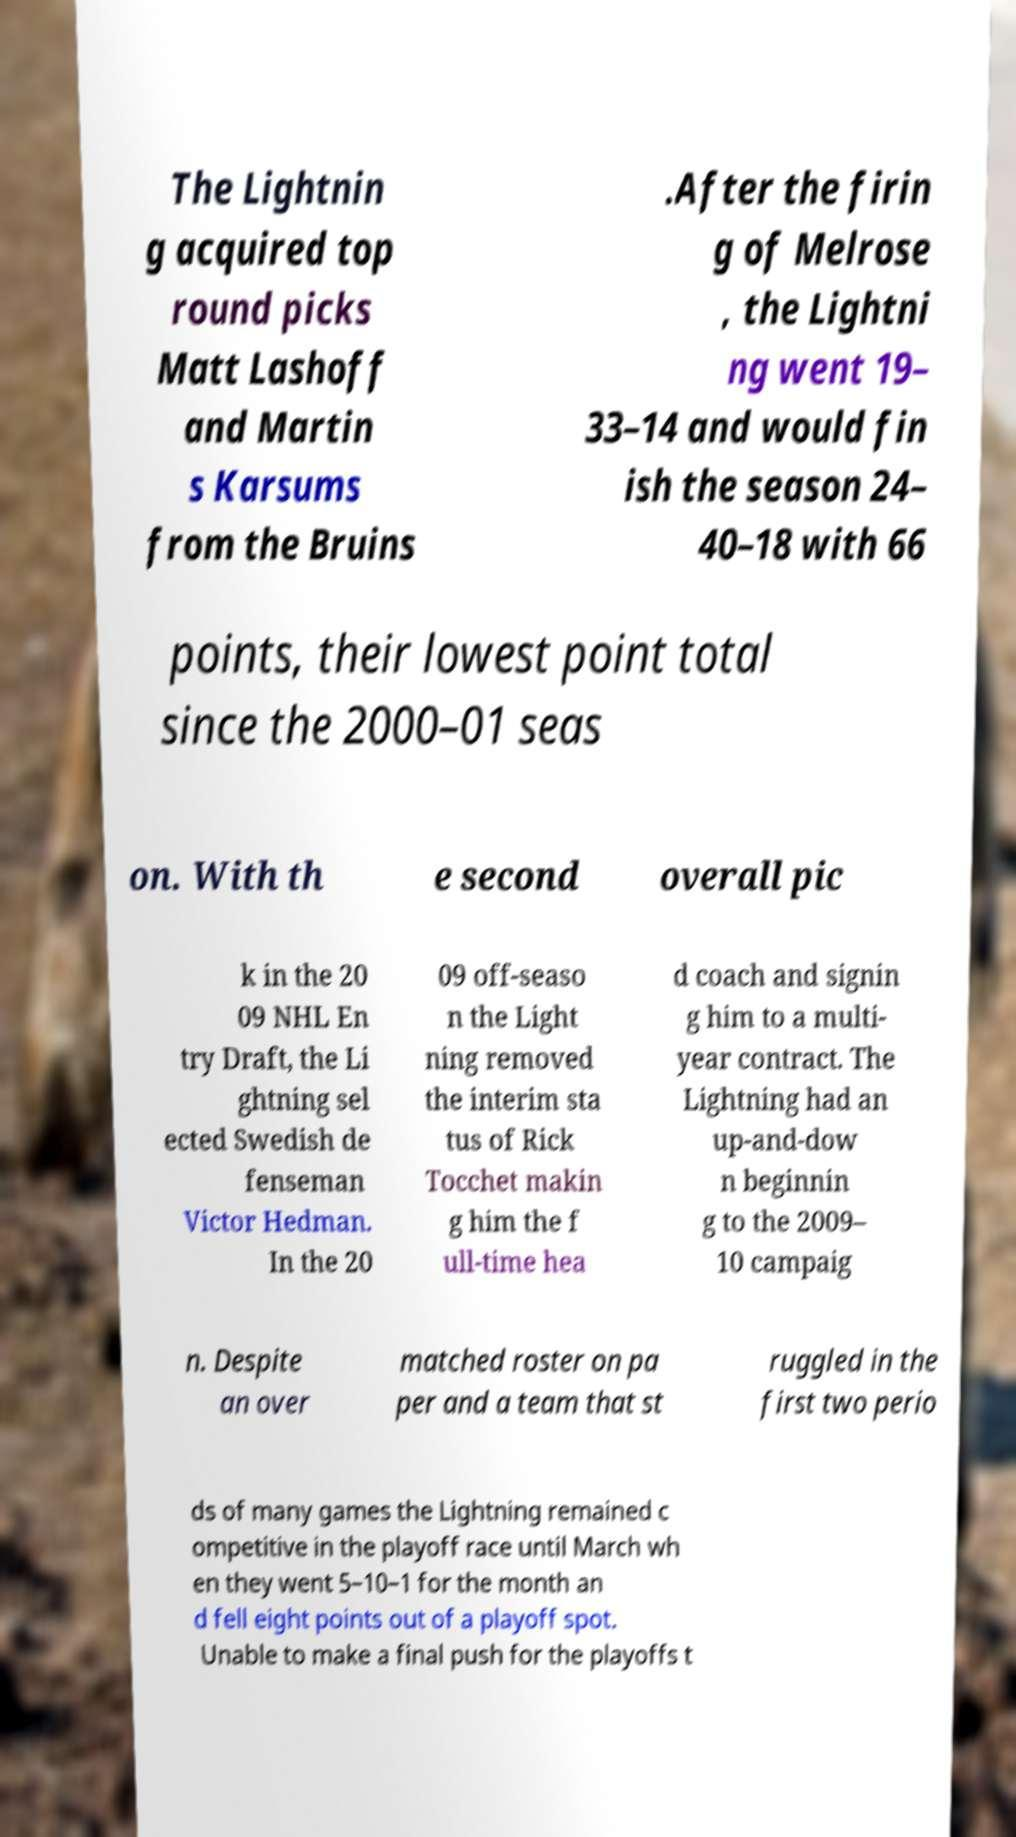Can you accurately transcribe the text from the provided image for me? The Lightnin g acquired top round picks Matt Lashoff and Martin s Karsums from the Bruins .After the firin g of Melrose , the Lightni ng went 19– 33–14 and would fin ish the season 24– 40–18 with 66 points, their lowest point total since the 2000–01 seas on. With th e second overall pic k in the 20 09 NHL En try Draft, the Li ghtning sel ected Swedish de fenseman Victor Hedman. In the 20 09 off-seaso n the Light ning removed the interim sta tus of Rick Tocchet makin g him the f ull-time hea d coach and signin g him to a multi- year contract. The Lightning had an up-and-dow n beginnin g to the 2009– 10 campaig n. Despite an over matched roster on pa per and a team that st ruggled in the first two perio ds of many games the Lightning remained c ompetitive in the playoff race until March wh en they went 5–10–1 for the month an d fell eight points out of a playoff spot. Unable to make a final push for the playoffs t 